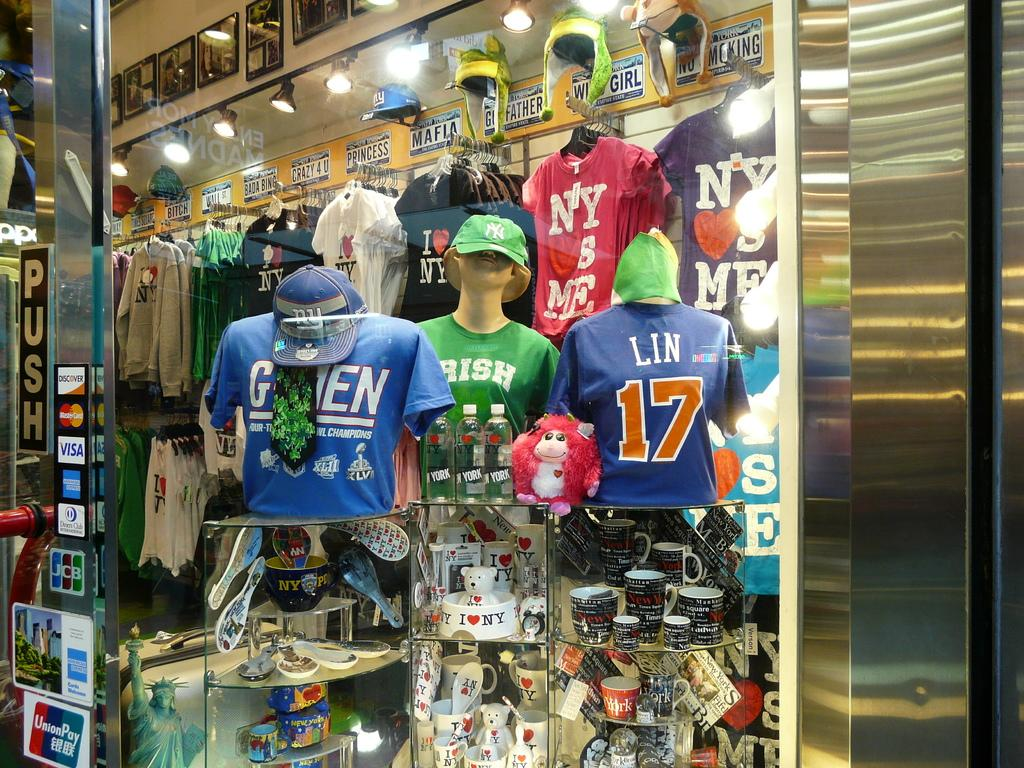<image>
Create a compact narrative representing the image presented. a storefront with a window that shows jersey number shirts for different teams, one of them is the number 17 for Lin 